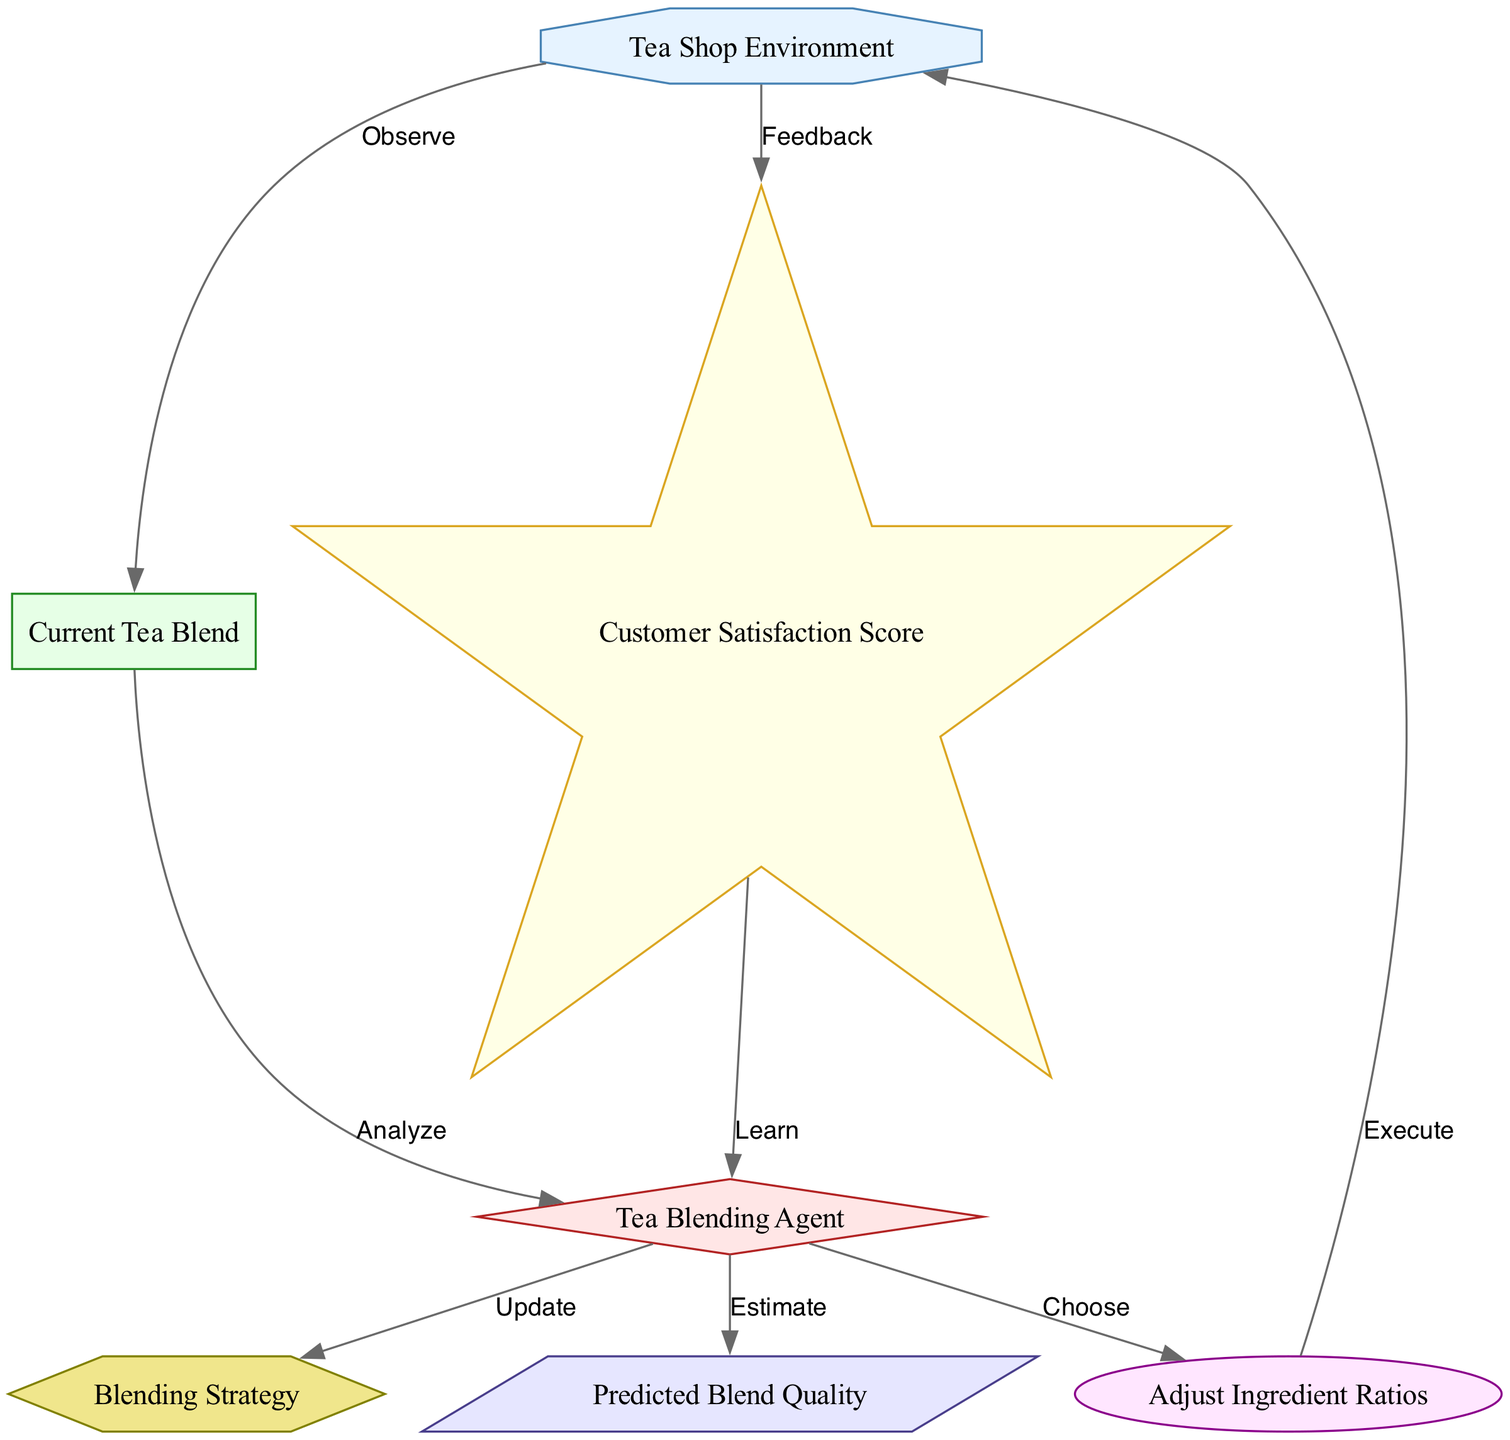What is the shape of the "Tea Blending Agent" node? The "Tea Blending Agent" node is represented by a diamond shape according to the node styling in the diagram.
Answer: diamond How many nodes are present in the diagram? The diagram contains a total of 7 nodes as listed: Tea Shop Environment, Tea Blending Agent, Current Tea Blend, Adjust Ingredient Ratios, Customer Satisfaction Score, Blending Strategy, and Predicted Blend Quality.
Answer: 7 What label is associated with the action taken by the agent? The label associated with the action taken by the agent is "Adjust Ingredient Ratios," which indicates the specific action the agent chooses to execute.
Answer: Adjust Ingredient Ratios Which two nodes have a feedback relationship? The nodes with a feedback relationship are "Customer Satisfaction Score" and "Tea Blending Agent," where the agent learns from the feedback received after executing an action in the environment.
Answer: Customer Satisfaction Score and Tea Blending Agent What directs the agent's next step after analyzing the current tea blend? After analyzing the current tea blend, the agent's next step is directed by choosing an action, specifically "Adjust Ingredient Ratios," as indicated by the relationship in the diagram.
Answer: Choose How does the environment communicate the current tea blend to the agent? The environment communicates the current tea blend to the agent through the "Observe" relationship, as shown in the directed edge from the environment to the state, indicating that the agent observes the current tea blend state.
Answer: Observe What happens after the agent executes the chosen action? After the agent executes the chosen action, feedback is received from the environment as indicated by the directed relationship labeled "Feedback," which helps the agent learn from customer satisfaction results.
Answer: Feedback Which node is updated based on the agent's actions? The node updated based on the agent's actions is the "Blending Strategy," as the agent regularly updates its policy based on experiential learning from successive interactions with the environment.
Answer: Blending Strategy What type of value does the "Predicted Blend Quality" node represent? The "Predicted Blend Quality" node represents an estimation value that the agent calculates to assess the quality of the herbal blend based on selected ingredient ratios and customer feedback.
Answer: Estimation 